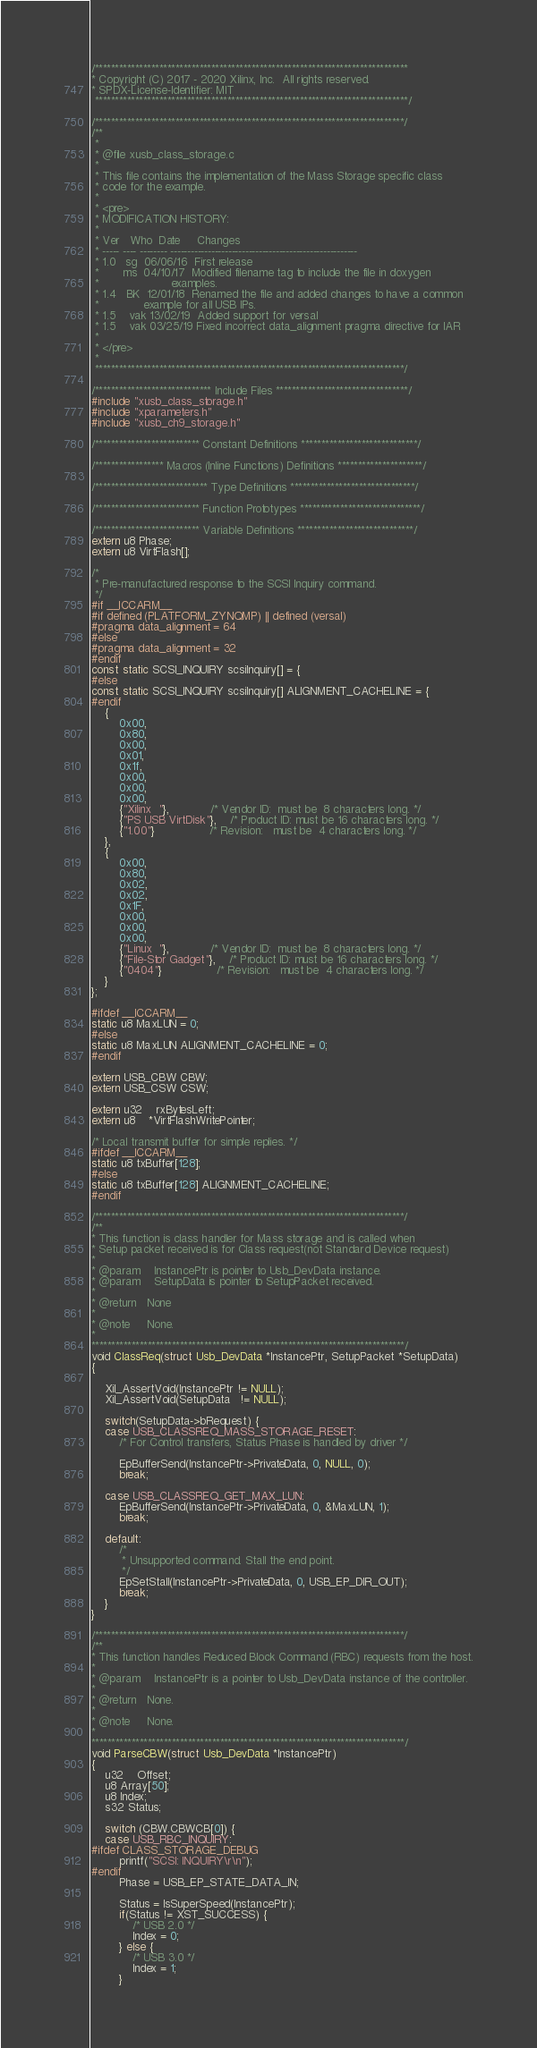Convert code to text. <code><loc_0><loc_0><loc_500><loc_500><_C_>/******************************************************************************
* Copyright (C) 2017 - 2020 Xilinx, Inc.  All rights reserved.
* SPDX-License-Identifier: MIT
 ******************************************************************************/

/*****************************************************************************/
/**
 *
 * @file xusb_class_storage.c
 *
 * This file contains the implementation of the Mass Storage specific class
 * code for the example.
 *
 * <pre>
 * MODIFICATION HISTORY:
 *
 * Ver   Who  Date     Changes
 * ----- ---- -------- -------------------------------------------------------
 * 1.0   sg  06/06/16  First release
 *       ms  04/10/17  Modified filename tag to include the file in doxygen
 *                     examples.
 * 1.4   BK  12/01/18  Renamed the file and added changes to have a common
 *		       example for all USB IPs.
 * 1.5	  vak 13/02/19  Added support for versal
 * 1.5    vak 03/25/19 Fixed incorrect data_alignment pragma directive for IAR
 *
 * </pre>
 *
 *****************************************************************************/

/***************************** Include Files *********************************/
#include "xusb_class_storage.h"
#include "xparameters.h"
#include "xusb_ch9_storage.h"

/************************** Constant Definitions *****************************/

/***************** Macros (Inline Functions) Definitions *********************/

/**************************** Type Definitions *******************************/

/************************** Function Prototypes ******************************/

/************************** Variable Definitions *****************************/
extern u8 Phase;
extern u8 VirtFlash[];

/*
 * Pre-manufactured response to the SCSI Inquiry command.
 */
#if __ICCARM__
#if defined (PLATFORM_ZYNQMP) || defined (versal)
#pragma data_alignment = 64
#else
#pragma data_alignment = 32
#endif
const static SCSI_INQUIRY scsiInquiry[] = {
#else
const static SCSI_INQUIRY scsiInquiry[] ALIGNMENT_CACHELINE = {
#endif
	{
		0x00,
		0x80,
		0x00,
		0x01,
		0x1f,
		0x00,
		0x00,
		0x00,
		{"Xilinx  "},			/* Vendor ID:  must be  8 characters long. */
		{"PS USB VirtDisk"},	/* Product ID: must be 16 characters long. */
		{"1.00"}				/* Revision:   must be  4 characters long. */
	},
	{
		0x00,
		0x80,
		0x02,
		0x02,
		0x1F,
		0x00,
		0x00,
		0x00,
		{"Linux  "},			/* Vendor ID:  must be  8 characters long. */
		{"File-Stor Gadget"},	/* Product ID: must be 16 characters long. */
		{"0404"}				/* Revision:   must be  4 characters long. */
	}
};

#ifdef __ICCARM__
static u8 MaxLUN = 0;
#else
static u8 MaxLUN ALIGNMENT_CACHELINE = 0;
#endif

extern USB_CBW CBW;
extern USB_CSW CSW;

extern u32	rxBytesLeft;
extern u8	*VirtFlashWritePointer;

/* Local transmit buffer for simple replies. */
#ifdef __ICCARM__
static u8 txBuffer[128];
#else
static u8 txBuffer[128] ALIGNMENT_CACHELINE;
#endif

/*****************************************************************************/
/**
* This function is class handler for Mass storage and is called when
* Setup packet received is for Class request(not Standard Device request)
*
* @param	InstancePtr is pointer to Usb_DevData instance.
* @param	SetupData is pointer to SetupPacket received.
*
* @return	None
*
* @note		None.
*
******************************************************************************/
void ClassReq(struct Usb_DevData *InstancePtr, SetupPacket *SetupData)
{

	Xil_AssertVoid(InstancePtr != NULL);
	Xil_AssertVoid(SetupData   != NULL);

	switch(SetupData->bRequest) {
	case USB_CLASSREQ_MASS_STORAGE_RESET:
		/* For Control transfers, Status Phase is handled by driver */

		EpBufferSend(InstancePtr->PrivateData, 0, NULL, 0);
		break;

	case USB_CLASSREQ_GET_MAX_LUN:
		EpBufferSend(InstancePtr->PrivateData, 0, &MaxLUN, 1);
		break;

	default:
		/*
		 * Unsupported command. Stall the end point.
		 */
		EpSetStall(InstancePtr->PrivateData, 0, USB_EP_DIR_OUT);
		break;
	}
}

/*****************************************************************************/
/**
* This function handles Reduced Block Command (RBC) requests from the host.
*
* @param	InstancePtr is a pointer to Usb_DevData instance of the controller.
*
* @return	None.
*
* @note		None.
*
******************************************************************************/
void ParseCBW(struct Usb_DevData *InstancePtr)
{
	u32	Offset;
	u8 Array[50];
	u8 Index;
	s32 Status;

	switch (CBW.CBWCB[0]) {
	case USB_RBC_INQUIRY:
#ifdef CLASS_STORAGE_DEBUG
		printf("SCSI: INQUIRY\r\n");
#endif
		Phase = USB_EP_STATE_DATA_IN;

		Status = IsSuperSpeed(InstancePtr);
		if(Status != XST_SUCCESS) {
			/* USB 2.0 */
			Index = 0;
		} else {
			/* USB 3.0 */
			Index = 1;
		}
</code> 